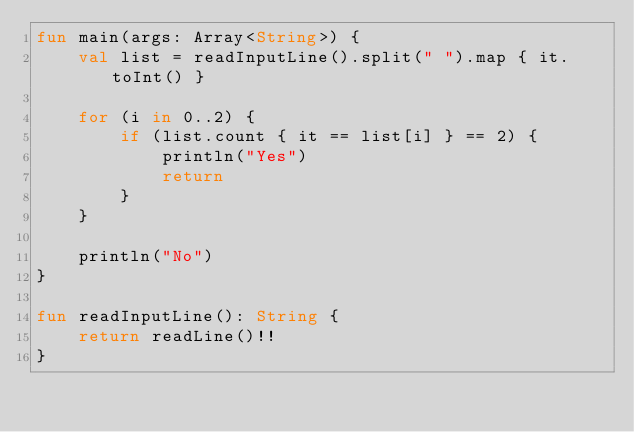<code> <loc_0><loc_0><loc_500><loc_500><_Kotlin_>fun main(args: Array<String>) {
    val list = readInputLine().split(" ").map { it.toInt() }

    for (i in 0..2) {
        if (list.count { it == list[i] } == 2) {
            println("Yes")
            return
        }
    }

    println("No")
}

fun readInputLine(): String {
    return readLine()!!
}
</code> 